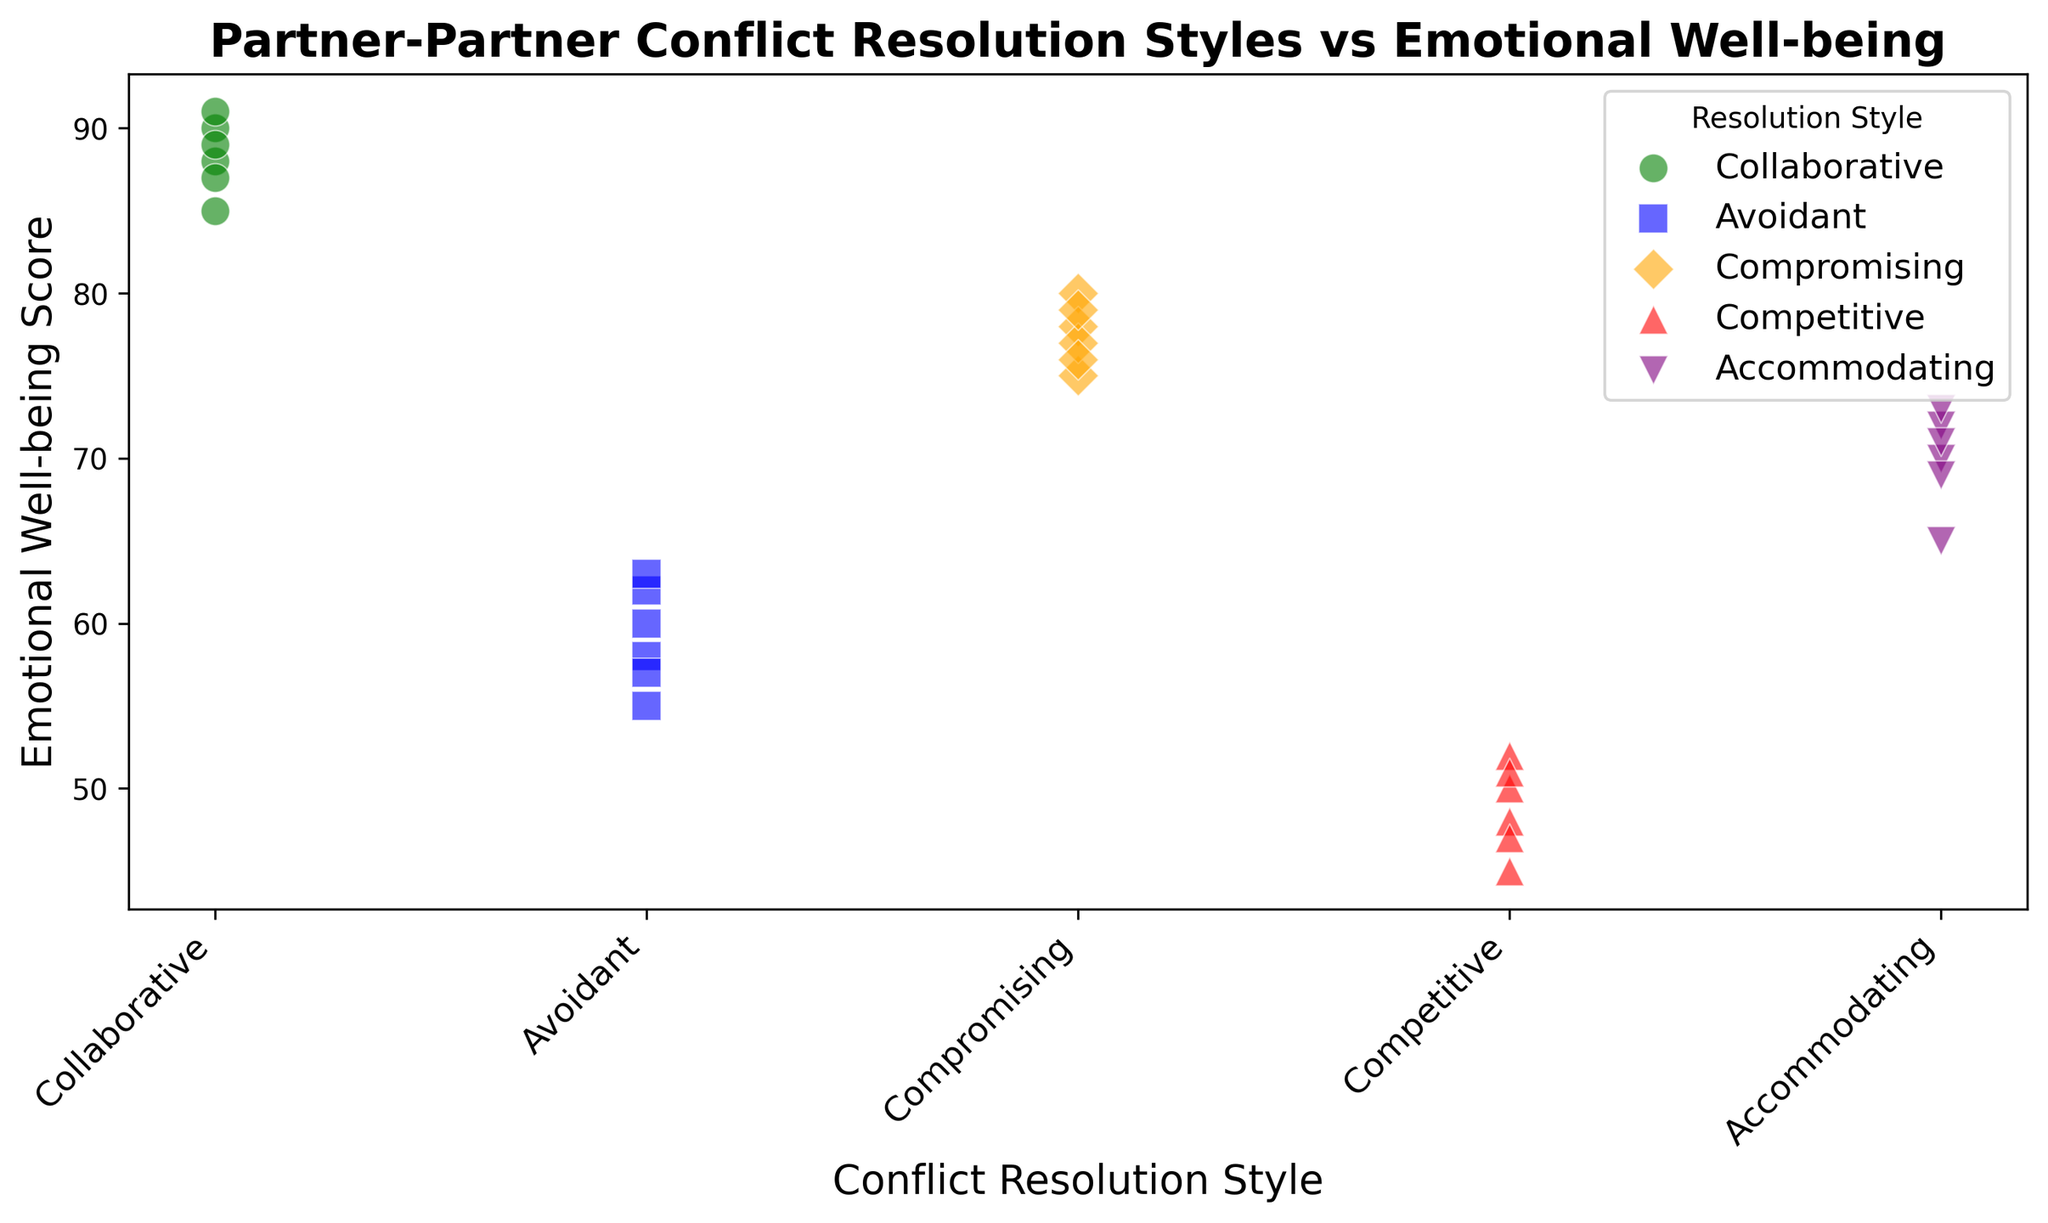What's the average Emotional Well-being Score for the Competitive resolution style? First, identify all data points related to the Competitive style (50, 45, 52, 48, 47, 51). Sum these scores (50 + 45 + 52 + 48 + 47 + 51 = 293). Divide by the number of data points (6). The average is 293 / 6 = 48.83
Answer: 48.83 Which conflict resolution style has the highest range in Emotional Well-being Scores? The range is calculated as the difference between the highest and lowest scores within each style. Collaborative: 91 - 85 = 6; Avoidant: 63 - 55 = 8; Compromising: 80 - 75 = 5; Competitive: 52 - 45 = 7; Accommodating: 73 - 65 = 8. Both Avoidant and Accommodating have the highest range of 8.
Answer: Avoidant, Accommodating Are the Emotional Well-being Scores more clustered for Collaborative or Avoidant resolution styles? Visualize the scatter points for Collaborative and Avoidant styles. Collaborative scores (85, 90, 88, 87, 91, 89) are more tightly clustered versus Avoidant scores (60, 55, 58, 62, 57, 63), which appear more spread out. Thus, the Collaborative style shows more clustering.
Answer: Collaborative What is the median Emotional Well-being Score for the Accommodating resolution style? First, list Accommodating scores in ascending order: (65, 69, 70, 71, 72, 73). For an even number of scores, the median is the average of the middle two. (70 + 71) / 2 = 70.5
Answer: 70.5 Compare the maximum Emotional Well-being Scores between Collaborative and Compromising styles. Which is higher? The maximum scores for Collaborative and Compromising are identified as 91 and 80, respectively. Thus, the Collaborative style has a higher maximum score.
Answer: Collaborative 